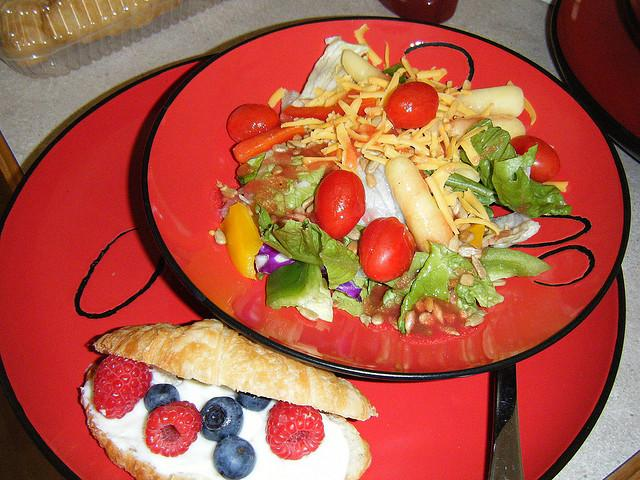How many items qualify as a berry botanically? Please explain your reasoning. two. Because of its red color and its appearance. 